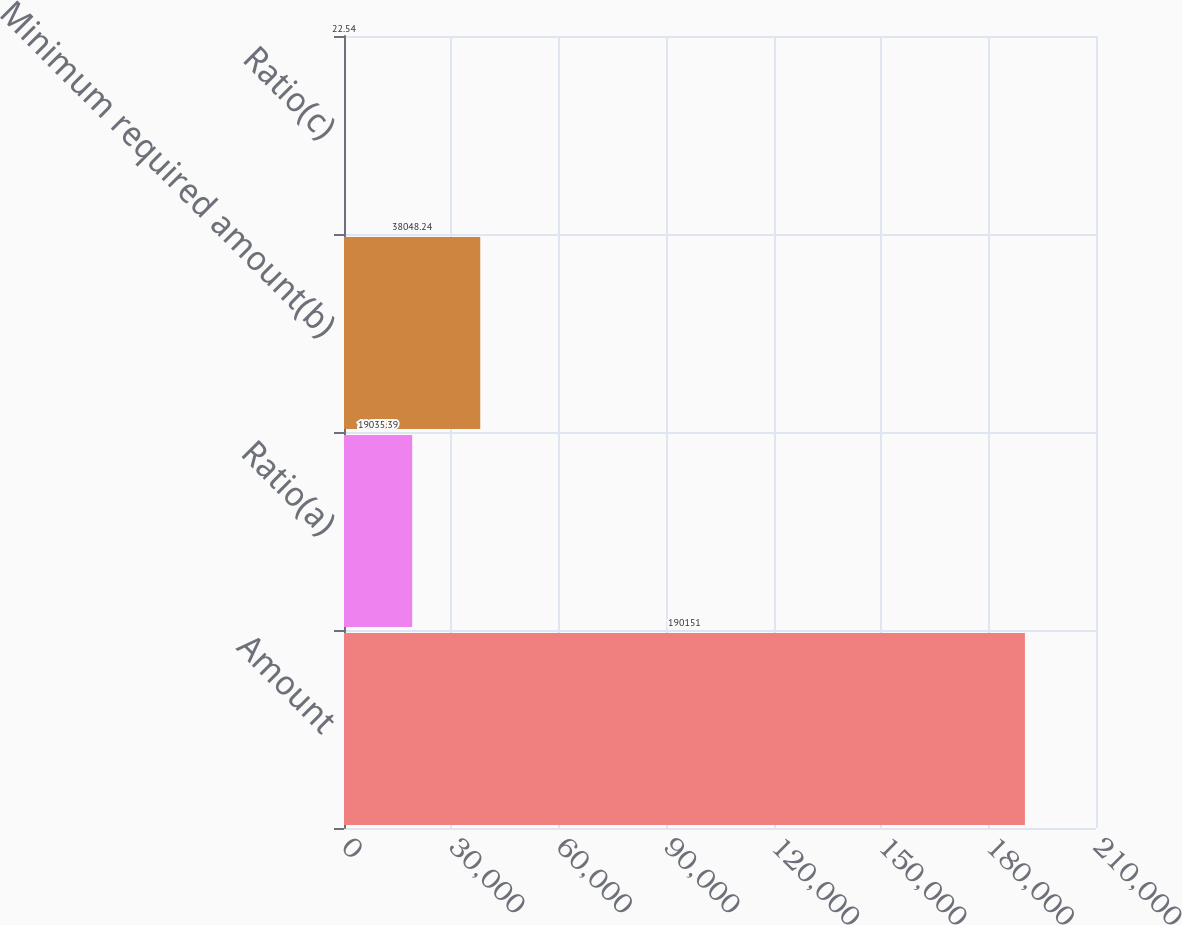Convert chart. <chart><loc_0><loc_0><loc_500><loc_500><bar_chart><fcel>Amount<fcel>Ratio(a)<fcel>Minimum required amount(b)<fcel>Ratio(c)<nl><fcel>190151<fcel>19035.4<fcel>38048.2<fcel>22.54<nl></chart> 